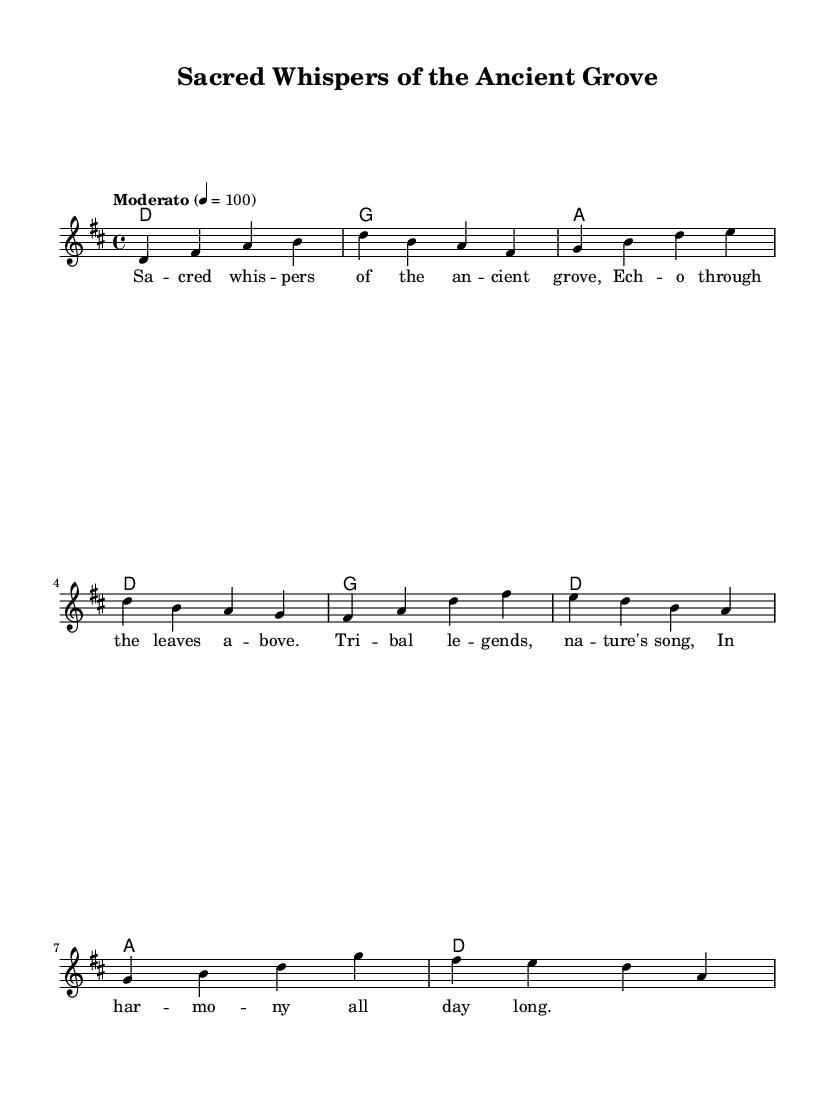What is the key signature of this music? The key signature is D major, which has two sharps: F# and C#. This can be determined by looking at the beginning of the staff, where the sharps are indicated.
Answer: D major What is the time signature of this music? The time signature is 4/4, which is indicated at the beginning of the staff. This means there are four beats in each measure and the quarter note gets one beat.
Answer: 4/4 What is the tempo marking of this music? The tempo marking is "Moderato", which suggests a moderate speed. This is mentioned near the beginning of the score, alongside the metronome marking of 100 beats per minute.
Answer: Moderato How many measures are in the melody section? The melody section contains 8 measures, which can be counted by looking at the grouping of notes on the staff and identifying the bar lines that separate them.
Answer: 8 What is the first note of the melody? The first note of the melody is D, which is located at the start of the melody line. This note is indicated by the position on the staff.
Answer: D How many chords are used in the harmonies? There are four different chords used in the harmonies: D, G, and A. This can be confirmed by examining the chord names above the staff and counting the unique chord types.
Answer: 3 What theme does the song evoke related to its title? The theme evokes nature and connectedness to sacred forests, as indicated by the title "Sacred Whispers of the Ancient Grove". This title hints at deep cultural and environmental ties, common in folk narratives.
Answer: Nature 